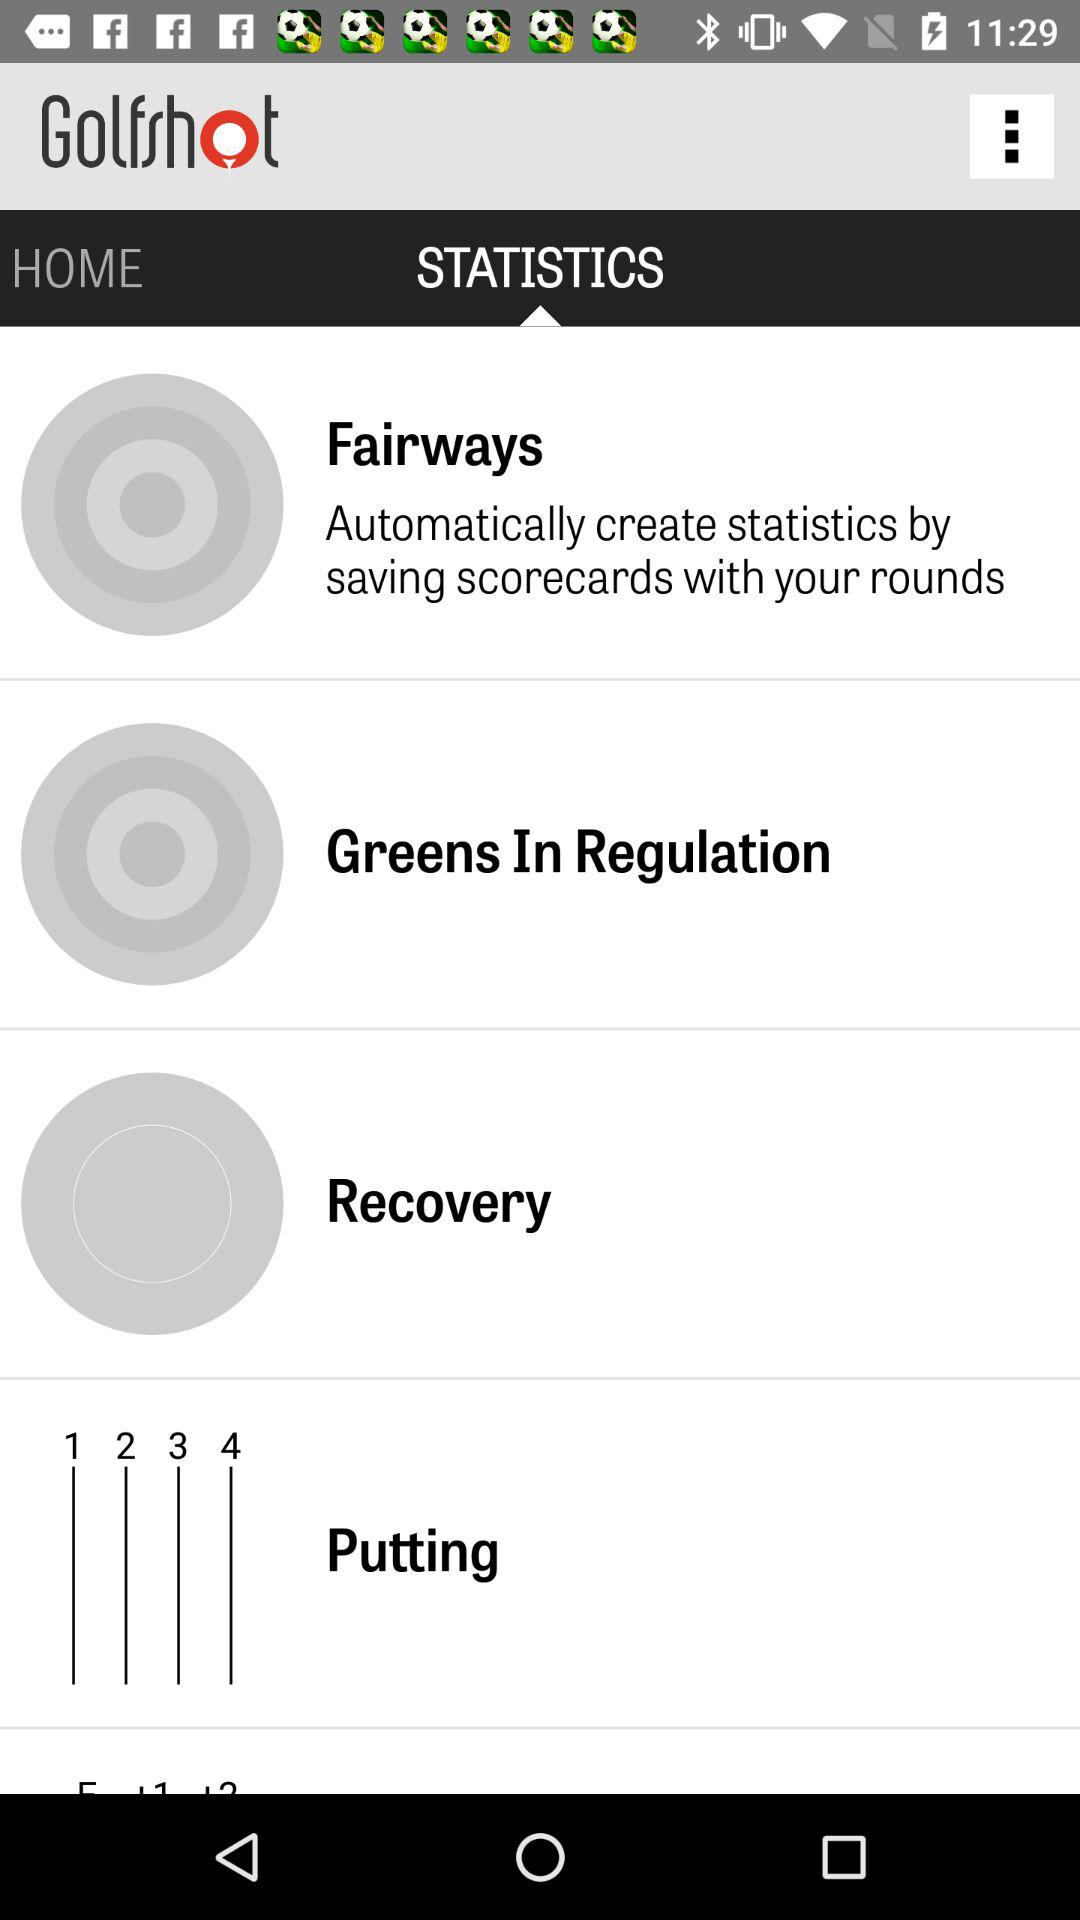What is the user's name?
When the provided information is insufficient, respond with <no answer>. <no answer> 